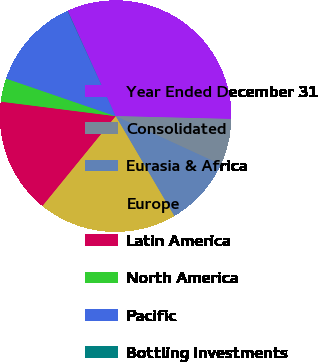Convert chart to OTSL. <chart><loc_0><loc_0><loc_500><loc_500><pie_chart><fcel>Year Ended December 31<fcel>Consolidated<fcel>Eurasia & Africa<fcel>Europe<fcel>Latin America<fcel>North America<fcel>Pacific<fcel>Bottling Investments<nl><fcel>32.19%<fcel>6.47%<fcel>9.69%<fcel>19.33%<fcel>16.12%<fcel>3.26%<fcel>12.9%<fcel>0.04%<nl></chart> 